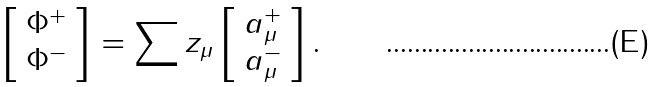<formula> <loc_0><loc_0><loc_500><loc_500>\left [ \begin{array} { c } \Phi ^ { + } \\ \Phi ^ { - } \end{array} \right ] = \sum z _ { \mu } \left [ \begin{array} { c } a _ { \mu } ^ { + } \\ a _ { \mu } ^ { - } \end{array} \right ] .</formula> 